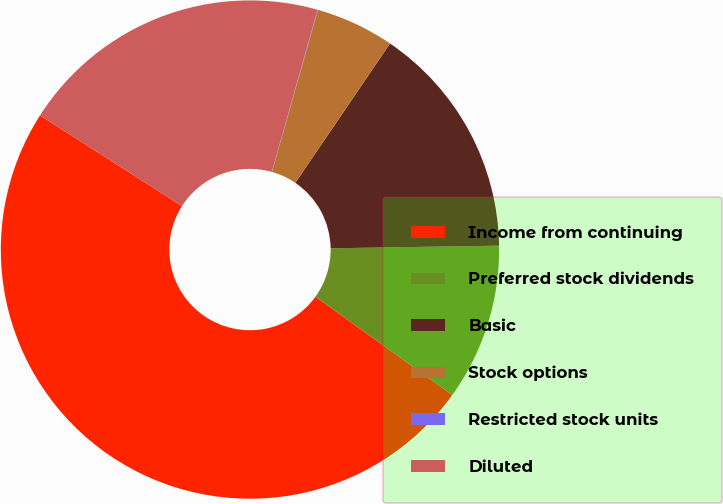Convert chart to OTSL. <chart><loc_0><loc_0><loc_500><loc_500><pie_chart><fcel>Income from continuing<fcel>Preferred stock dividends<fcel>Basic<fcel>Stock options<fcel>Restricted stock units<fcel>Diluted<nl><fcel>49.13%<fcel>10.17%<fcel>15.25%<fcel>5.1%<fcel>0.03%<fcel>20.32%<nl></chart> 